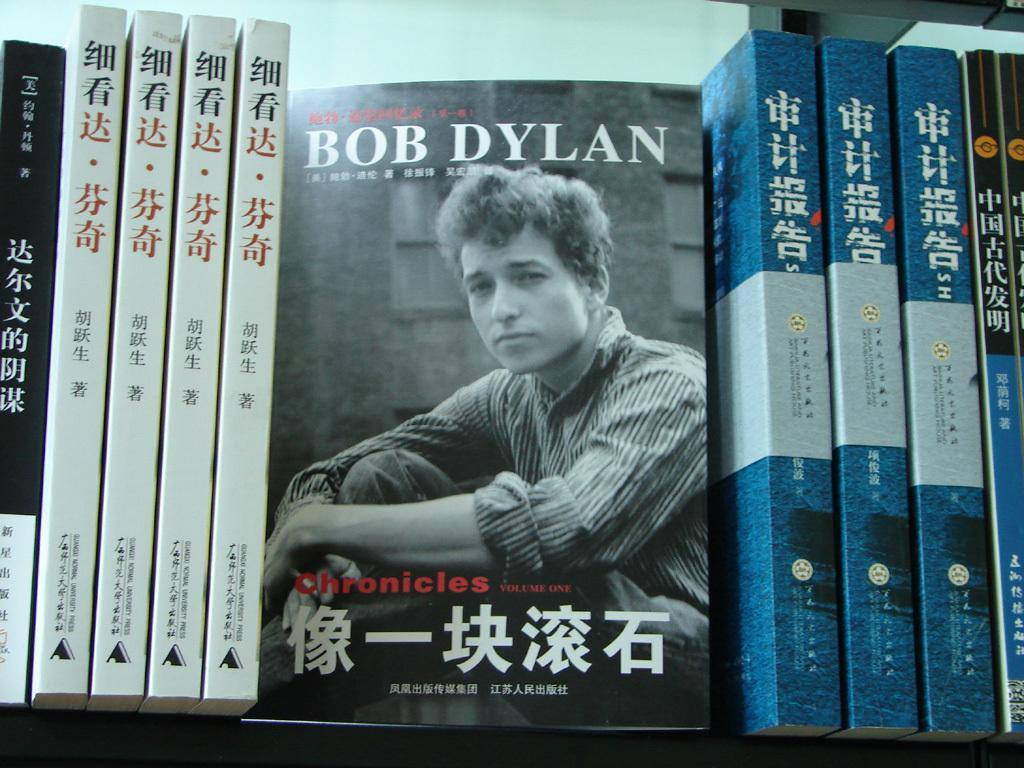<image>
Offer a succinct explanation of the picture presented. A bookshelf with a  Bob Dylan book in the middle 